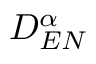Convert formula to latex. <formula><loc_0><loc_0><loc_500><loc_500>D _ { E N } ^ { \alpha }</formula> 